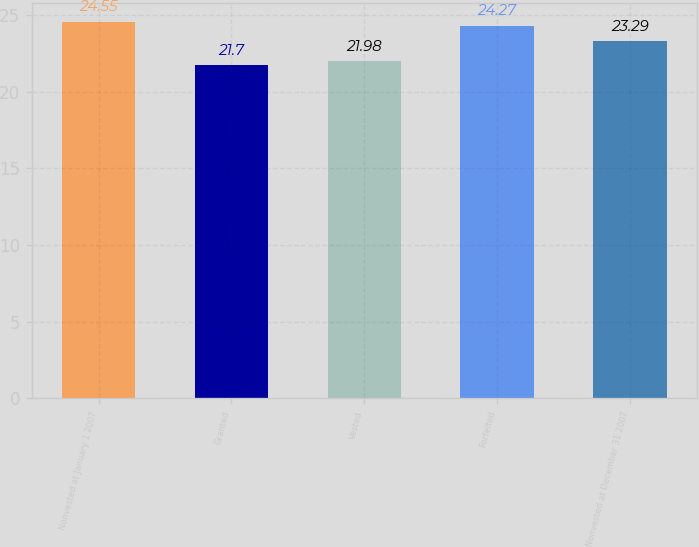Convert chart to OTSL. <chart><loc_0><loc_0><loc_500><loc_500><bar_chart><fcel>Nonvested at January 1 2007<fcel>Granted<fcel>Vested<fcel>Forfeited<fcel>Nonvested at December 31 2007<nl><fcel>24.55<fcel>21.7<fcel>21.98<fcel>24.27<fcel>23.29<nl></chart> 